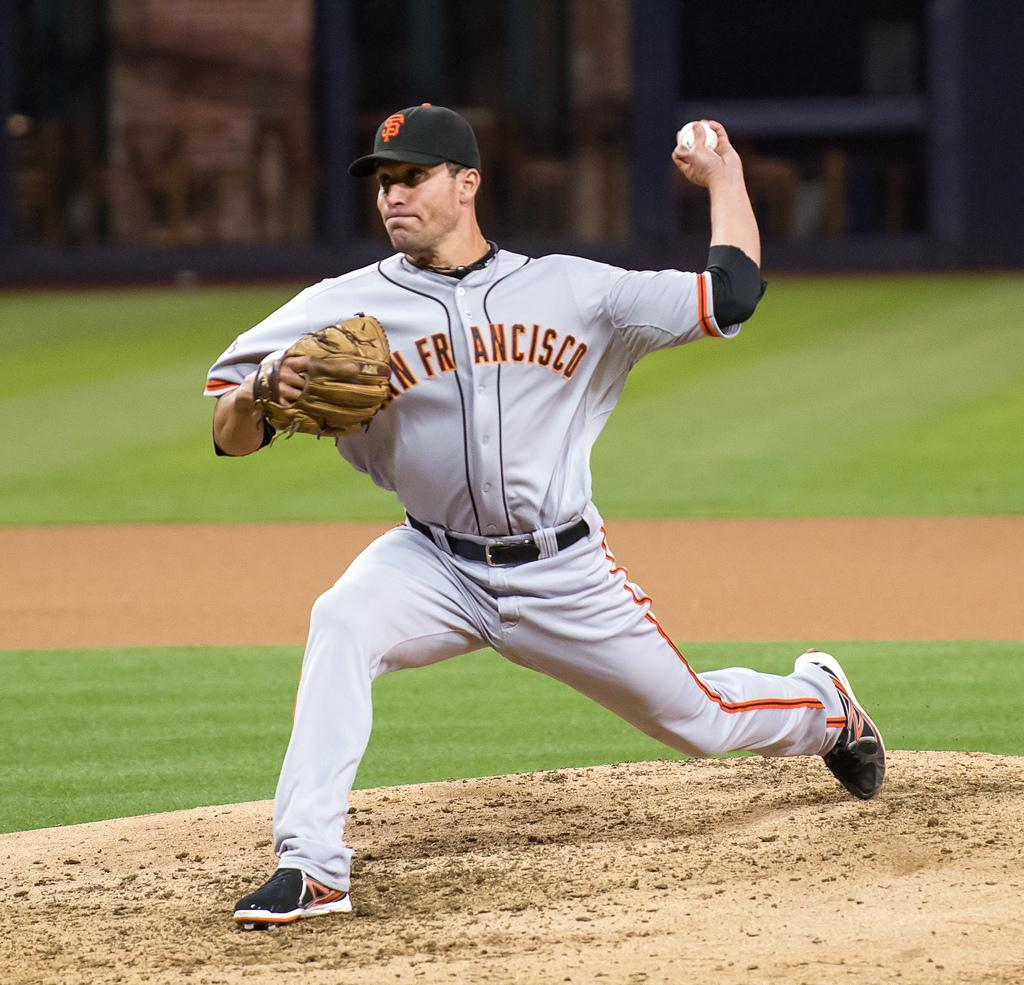<image>
Write a terse but informative summary of the picture. a man that is wearing a San Francisco jersey and playing baseball 